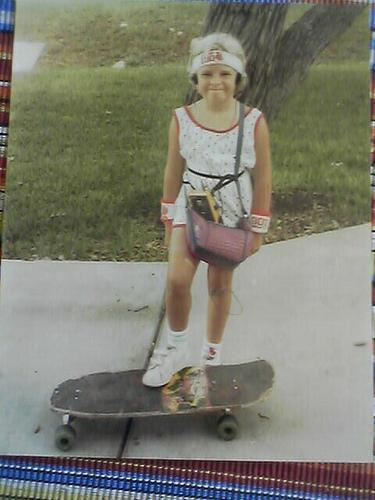How many boys are there?
Give a very brief answer. 0. How many skateboards are there?
Give a very brief answer. 1. 